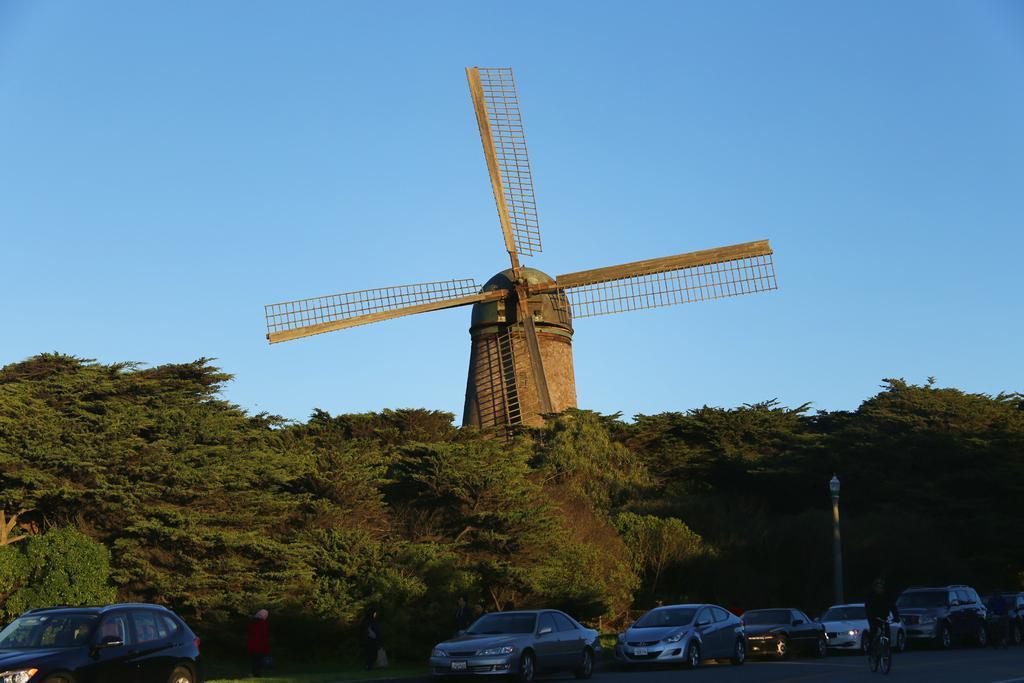In one or two sentences, can you explain what this image depicts? In the picture we can see some cars on the road and some pole and behind it, we can see a hill surface with plants and trees and the top of the hill we can see a windmill, and behind it we can see a sky. 